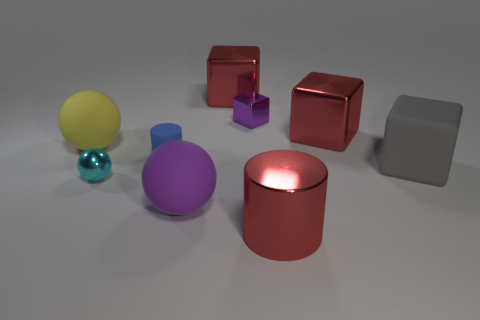What is the material of the big ball on the right side of the big matte thing that is on the left side of the sphere on the right side of the tiny matte thing?
Give a very brief answer. Rubber. How many other things are there of the same color as the small rubber cylinder?
Give a very brief answer. 0. How many brown things are cubes or big metallic cylinders?
Offer a terse response. 0. What is the material of the cylinder that is left of the shiny cylinder?
Provide a succinct answer. Rubber. Is the cylinder that is right of the purple metal object made of the same material as the big gray object?
Give a very brief answer. No. There is a big yellow object; what shape is it?
Keep it short and to the point. Sphere. How many matte objects are behind the tiny object in front of the big block in front of the big yellow rubber ball?
Make the answer very short. 3. What number of other objects are there of the same material as the gray block?
Ensure brevity in your answer.  3. There is another sphere that is the same size as the purple matte sphere; what material is it?
Your response must be concise. Rubber. There is a rubber ball that is right of the blue matte object; is its color the same as the tiny metal thing that is right of the large purple sphere?
Provide a short and direct response. Yes. 